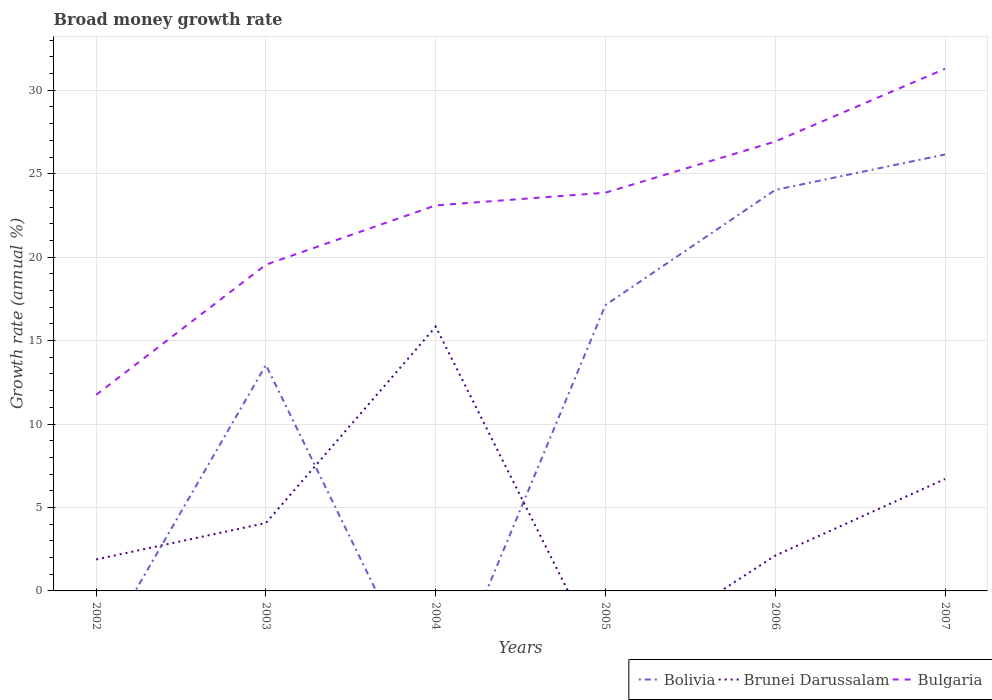How many different coloured lines are there?
Your answer should be compact. 3. Does the line corresponding to Bulgaria intersect with the line corresponding to Bolivia?
Offer a terse response. No. Is the number of lines equal to the number of legend labels?
Offer a terse response. No. Across all years, what is the maximum growth rate in Bulgaria?
Your response must be concise. 11.75. What is the total growth rate in Brunei Darussalam in the graph?
Provide a succinct answer. -4.82. What is the difference between the highest and the second highest growth rate in Bolivia?
Give a very brief answer. 26.15. Is the growth rate in Bulgaria strictly greater than the growth rate in Bolivia over the years?
Make the answer very short. No. How many lines are there?
Ensure brevity in your answer.  3. What is the difference between two consecutive major ticks on the Y-axis?
Provide a short and direct response. 5. Are the values on the major ticks of Y-axis written in scientific E-notation?
Give a very brief answer. No. Does the graph contain any zero values?
Provide a short and direct response. Yes. Does the graph contain grids?
Offer a terse response. Yes. Where does the legend appear in the graph?
Make the answer very short. Bottom right. How many legend labels are there?
Your answer should be compact. 3. What is the title of the graph?
Provide a succinct answer. Broad money growth rate. Does "Congo (Republic)" appear as one of the legend labels in the graph?
Keep it short and to the point. No. What is the label or title of the Y-axis?
Your answer should be compact. Growth rate (annual %). What is the Growth rate (annual %) in Brunei Darussalam in 2002?
Your answer should be compact. 1.89. What is the Growth rate (annual %) of Bulgaria in 2002?
Keep it short and to the point. 11.75. What is the Growth rate (annual %) of Bolivia in 2003?
Your response must be concise. 13.54. What is the Growth rate (annual %) in Brunei Darussalam in 2003?
Your response must be concise. 4.07. What is the Growth rate (annual %) of Bulgaria in 2003?
Offer a very short reply. 19.55. What is the Growth rate (annual %) of Brunei Darussalam in 2004?
Your answer should be very brief. 15.83. What is the Growth rate (annual %) in Bulgaria in 2004?
Your answer should be compact. 23.1. What is the Growth rate (annual %) in Bolivia in 2005?
Your answer should be compact. 17.13. What is the Growth rate (annual %) of Brunei Darussalam in 2005?
Make the answer very short. 0. What is the Growth rate (annual %) in Bulgaria in 2005?
Your answer should be compact. 23.86. What is the Growth rate (annual %) in Bolivia in 2006?
Provide a short and direct response. 24.03. What is the Growth rate (annual %) in Brunei Darussalam in 2006?
Give a very brief answer. 2.12. What is the Growth rate (annual %) of Bulgaria in 2006?
Keep it short and to the point. 26.93. What is the Growth rate (annual %) of Bolivia in 2007?
Ensure brevity in your answer.  26.15. What is the Growth rate (annual %) of Brunei Darussalam in 2007?
Keep it short and to the point. 6.71. What is the Growth rate (annual %) of Bulgaria in 2007?
Your answer should be very brief. 31.29. Across all years, what is the maximum Growth rate (annual %) of Bolivia?
Make the answer very short. 26.15. Across all years, what is the maximum Growth rate (annual %) of Brunei Darussalam?
Offer a very short reply. 15.83. Across all years, what is the maximum Growth rate (annual %) in Bulgaria?
Keep it short and to the point. 31.29. Across all years, what is the minimum Growth rate (annual %) of Bulgaria?
Offer a terse response. 11.75. What is the total Growth rate (annual %) in Bolivia in the graph?
Keep it short and to the point. 80.85. What is the total Growth rate (annual %) of Brunei Darussalam in the graph?
Ensure brevity in your answer.  30.61. What is the total Growth rate (annual %) of Bulgaria in the graph?
Your response must be concise. 136.47. What is the difference between the Growth rate (annual %) in Brunei Darussalam in 2002 and that in 2003?
Offer a terse response. -2.19. What is the difference between the Growth rate (annual %) in Bulgaria in 2002 and that in 2003?
Offer a terse response. -7.8. What is the difference between the Growth rate (annual %) of Brunei Darussalam in 2002 and that in 2004?
Offer a terse response. -13.95. What is the difference between the Growth rate (annual %) in Bulgaria in 2002 and that in 2004?
Give a very brief answer. -11.35. What is the difference between the Growth rate (annual %) in Bulgaria in 2002 and that in 2005?
Provide a succinct answer. -12.11. What is the difference between the Growth rate (annual %) of Brunei Darussalam in 2002 and that in 2006?
Keep it short and to the point. -0.23. What is the difference between the Growth rate (annual %) in Bulgaria in 2002 and that in 2006?
Your answer should be compact. -15.18. What is the difference between the Growth rate (annual %) of Brunei Darussalam in 2002 and that in 2007?
Give a very brief answer. -4.82. What is the difference between the Growth rate (annual %) in Bulgaria in 2002 and that in 2007?
Your response must be concise. -19.54. What is the difference between the Growth rate (annual %) in Brunei Darussalam in 2003 and that in 2004?
Provide a short and direct response. -11.76. What is the difference between the Growth rate (annual %) in Bulgaria in 2003 and that in 2004?
Keep it short and to the point. -3.55. What is the difference between the Growth rate (annual %) in Bolivia in 2003 and that in 2005?
Give a very brief answer. -3.59. What is the difference between the Growth rate (annual %) of Bulgaria in 2003 and that in 2005?
Provide a short and direct response. -4.31. What is the difference between the Growth rate (annual %) of Bolivia in 2003 and that in 2006?
Keep it short and to the point. -10.49. What is the difference between the Growth rate (annual %) of Brunei Darussalam in 2003 and that in 2006?
Ensure brevity in your answer.  1.95. What is the difference between the Growth rate (annual %) of Bulgaria in 2003 and that in 2006?
Your answer should be compact. -7.38. What is the difference between the Growth rate (annual %) of Bolivia in 2003 and that in 2007?
Make the answer very short. -12.61. What is the difference between the Growth rate (annual %) in Brunei Darussalam in 2003 and that in 2007?
Your response must be concise. -2.64. What is the difference between the Growth rate (annual %) of Bulgaria in 2003 and that in 2007?
Make the answer very short. -11.74. What is the difference between the Growth rate (annual %) of Bulgaria in 2004 and that in 2005?
Offer a terse response. -0.76. What is the difference between the Growth rate (annual %) in Brunei Darussalam in 2004 and that in 2006?
Your answer should be very brief. 13.72. What is the difference between the Growth rate (annual %) of Bulgaria in 2004 and that in 2006?
Provide a short and direct response. -3.83. What is the difference between the Growth rate (annual %) in Brunei Darussalam in 2004 and that in 2007?
Keep it short and to the point. 9.13. What is the difference between the Growth rate (annual %) of Bulgaria in 2004 and that in 2007?
Keep it short and to the point. -8.19. What is the difference between the Growth rate (annual %) of Bolivia in 2005 and that in 2006?
Your response must be concise. -6.89. What is the difference between the Growth rate (annual %) in Bulgaria in 2005 and that in 2006?
Provide a succinct answer. -3.07. What is the difference between the Growth rate (annual %) of Bolivia in 2005 and that in 2007?
Offer a terse response. -9.02. What is the difference between the Growth rate (annual %) in Bulgaria in 2005 and that in 2007?
Offer a very short reply. -7.42. What is the difference between the Growth rate (annual %) of Bolivia in 2006 and that in 2007?
Ensure brevity in your answer.  -2.12. What is the difference between the Growth rate (annual %) in Brunei Darussalam in 2006 and that in 2007?
Your answer should be compact. -4.59. What is the difference between the Growth rate (annual %) of Bulgaria in 2006 and that in 2007?
Provide a succinct answer. -4.36. What is the difference between the Growth rate (annual %) of Brunei Darussalam in 2002 and the Growth rate (annual %) of Bulgaria in 2003?
Give a very brief answer. -17.66. What is the difference between the Growth rate (annual %) in Brunei Darussalam in 2002 and the Growth rate (annual %) in Bulgaria in 2004?
Your answer should be very brief. -21.22. What is the difference between the Growth rate (annual %) in Brunei Darussalam in 2002 and the Growth rate (annual %) in Bulgaria in 2005?
Offer a terse response. -21.98. What is the difference between the Growth rate (annual %) of Brunei Darussalam in 2002 and the Growth rate (annual %) of Bulgaria in 2006?
Your response must be concise. -25.04. What is the difference between the Growth rate (annual %) of Brunei Darussalam in 2002 and the Growth rate (annual %) of Bulgaria in 2007?
Offer a very short reply. -29.4. What is the difference between the Growth rate (annual %) of Bolivia in 2003 and the Growth rate (annual %) of Brunei Darussalam in 2004?
Give a very brief answer. -2.29. What is the difference between the Growth rate (annual %) in Bolivia in 2003 and the Growth rate (annual %) in Bulgaria in 2004?
Your response must be concise. -9.56. What is the difference between the Growth rate (annual %) in Brunei Darussalam in 2003 and the Growth rate (annual %) in Bulgaria in 2004?
Ensure brevity in your answer.  -19.03. What is the difference between the Growth rate (annual %) of Bolivia in 2003 and the Growth rate (annual %) of Bulgaria in 2005?
Your response must be concise. -10.32. What is the difference between the Growth rate (annual %) in Brunei Darussalam in 2003 and the Growth rate (annual %) in Bulgaria in 2005?
Give a very brief answer. -19.79. What is the difference between the Growth rate (annual %) of Bolivia in 2003 and the Growth rate (annual %) of Brunei Darussalam in 2006?
Your response must be concise. 11.42. What is the difference between the Growth rate (annual %) in Bolivia in 2003 and the Growth rate (annual %) in Bulgaria in 2006?
Keep it short and to the point. -13.39. What is the difference between the Growth rate (annual %) of Brunei Darussalam in 2003 and the Growth rate (annual %) of Bulgaria in 2006?
Your answer should be compact. -22.86. What is the difference between the Growth rate (annual %) in Bolivia in 2003 and the Growth rate (annual %) in Brunei Darussalam in 2007?
Your answer should be very brief. 6.83. What is the difference between the Growth rate (annual %) in Bolivia in 2003 and the Growth rate (annual %) in Bulgaria in 2007?
Offer a terse response. -17.75. What is the difference between the Growth rate (annual %) of Brunei Darussalam in 2003 and the Growth rate (annual %) of Bulgaria in 2007?
Offer a very short reply. -27.21. What is the difference between the Growth rate (annual %) of Brunei Darussalam in 2004 and the Growth rate (annual %) of Bulgaria in 2005?
Ensure brevity in your answer.  -8.03. What is the difference between the Growth rate (annual %) of Brunei Darussalam in 2004 and the Growth rate (annual %) of Bulgaria in 2006?
Make the answer very short. -11.09. What is the difference between the Growth rate (annual %) in Brunei Darussalam in 2004 and the Growth rate (annual %) in Bulgaria in 2007?
Offer a terse response. -15.45. What is the difference between the Growth rate (annual %) in Bolivia in 2005 and the Growth rate (annual %) in Brunei Darussalam in 2006?
Provide a succinct answer. 15.02. What is the difference between the Growth rate (annual %) in Bolivia in 2005 and the Growth rate (annual %) in Bulgaria in 2006?
Your response must be concise. -9.79. What is the difference between the Growth rate (annual %) of Bolivia in 2005 and the Growth rate (annual %) of Brunei Darussalam in 2007?
Make the answer very short. 10.43. What is the difference between the Growth rate (annual %) in Bolivia in 2005 and the Growth rate (annual %) in Bulgaria in 2007?
Ensure brevity in your answer.  -14.15. What is the difference between the Growth rate (annual %) in Bolivia in 2006 and the Growth rate (annual %) in Brunei Darussalam in 2007?
Give a very brief answer. 17.32. What is the difference between the Growth rate (annual %) in Bolivia in 2006 and the Growth rate (annual %) in Bulgaria in 2007?
Keep it short and to the point. -7.26. What is the difference between the Growth rate (annual %) of Brunei Darussalam in 2006 and the Growth rate (annual %) of Bulgaria in 2007?
Provide a short and direct response. -29.17. What is the average Growth rate (annual %) of Bolivia per year?
Ensure brevity in your answer.  13.48. What is the average Growth rate (annual %) of Brunei Darussalam per year?
Ensure brevity in your answer.  5.1. What is the average Growth rate (annual %) in Bulgaria per year?
Your response must be concise. 22.75. In the year 2002, what is the difference between the Growth rate (annual %) in Brunei Darussalam and Growth rate (annual %) in Bulgaria?
Ensure brevity in your answer.  -9.86. In the year 2003, what is the difference between the Growth rate (annual %) of Bolivia and Growth rate (annual %) of Brunei Darussalam?
Offer a very short reply. 9.47. In the year 2003, what is the difference between the Growth rate (annual %) in Bolivia and Growth rate (annual %) in Bulgaria?
Ensure brevity in your answer.  -6.01. In the year 2003, what is the difference between the Growth rate (annual %) of Brunei Darussalam and Growth rate (annual %) of Bulgaria?
Provide a short and direct response. -15.48. In the year 2004, what is the difference between the Growth rate (annual %) in Brunei Darussalam and Growth rate (annual %) in Bulgaria?
Ensure brevity in your answer.  -7.27. In the year 2005, what is the difference between the Growth rate (annual %) of Bolivia and Growth rate (annual %) of Bulgaria?
Ensure brevity in your answer.  -6.73. In the year 2006, what is the difference between the Growth rate (annual %) of Bolivia and Growth rate (annual %) of Brunei Darussalam?
Give a very brief answer. 21.91. In the year 2006, what is the difference between the Growth rate (annual %) of Bolivia and Growth rate (annual %) of Bulgaria?
Your answer should be very brief. -2.9. In the year 2006, what is the difference between the Growth rate (annual %) in Brunei Darussalam and Growth rate (annual %) in Bulgaria?
Offer a very short reply. -24.81. In the year 2007, what is the difference between the Growth rate (annual %) of Bolivia and Growth rate (annual %) of Brunei Darussalam?
Keep it short and to the point. 19.44. In the year 2007, what is the difference between the Growth rate (annual %) of Bolivia and Growth rate (annual %) of Bulgaria?
Your answer should be compact. -5.14. In the year 2007, what is the difference between the Growth rate (annual %) of Brunei Darussalam and Growth rate (annual %) of Bulgaria?
Offer a very short reply. -24.58. What is the ratio of the Growth rate (annual %) in Brunei Darussalam in 2002 to that in 2003?
Keep it short and to the point. 0.46. What is the ratio of the Growth rate (annual %) in Bulgaria in 2002 to that in 2003?
Provide a succinct answer. 0.6. What is the ratio of the Growth rate (annual %) in Brunei Darussalam in 2002 to that in 2004?
Give a very brief answer. 0.12. What is the ratio of the Growth rate (annual %) in Bulgaria in 2002 to that in 2004?
Ensure brevity in your answer.  0.51. What is the ratio of the Growth rate (annual %) in Bulgaria in 2002 to that in 2005?
Your answer should be very brief. 0.49. What is the ratio of the Growth rate (annual %) of Brunei Darussalam in 2002 to that in 2006?
Provide a succinct answer. 0.89. What is the ratio of the Growth rate (annual %) of Bulgaria in 2002 to that in 2006?
Offer a very short reply. 0.44. What is the ratio of the Growth rate (annual %) in Brunei Darussalam in 2002 to that in 2007?
Offer a very short reply. 0.28. What is the ratio of the Growth rate (annual %) in Bulgaria in 2002 to that in 2007?
Your answer should be compact. 0.38. What is the ratio of the Growth rate (annual %) in Brunei Darussalam in 2003 to that in 2004?
Your answer should be very brief. 0.26. What is the ratio of the Growth rate (annual %) of Bulgaria in 2003 to that in 2004?
Your answer should be compact. 0.85. What is the ratio of the Growth rate (annual %) of Bolivia in 2003 to that in 2005?
Make the answer very short. 0.79. What is the ratio of the Growth rate (annual %) of Bulgaria in 2003 to that in 2005?
Give a very brief answer. 0.82. What is the ratio of the Growth rate (annual %) in Bolivia in 2003 to that in 2006?
Offer a terse response. 0.56. What is the ratio of the Growth rate (annual %) of Brunei Darussalam in 2003 to that in 2006?
Provide a succinct answer. 1.92. What is the ratio of the Growth rate (annual %) of Bulgaria in 2003 to that in 2006?
Ensure brevity in your answer.  0.73. What is the ratio of the Growth rate (annual %) of Bolivia in 2003 to that in 2007?
Provide a short and direct response. 0.52. What is the ratio of the Growth rate (annual %) of Brunei Darussalam in 2003 to that in 2007?
Your answer should be compact. 0.61. What is the ratio of the Growth rate (annual %) of Bulgaria in 2003 to that in 2007?
Offer a very short reply. 0.62. What is the ratio of the Growth rate (annual %) of Bulgaria in 2004 to that in 2005?
Ensure brevity in your answer.  0.97. What is the ratio of the Growth rate (annual %) in Brunei Darussalam in 2004 to that in 2006?
Offer a terse response. 7.48. What is the ratio of the Growth rate (annual %) of Bulgaria in 2004 to that in 2006?
Make the answer very short. 0.86. What is the ratio of the Growth rate (annual %) in Brunei Darussalam in 2004 to that in 2007?
Your answer should be very brief. 2.36. What is the ratio of the Growth rate (annual %) in Bulgaria in 2004 to that in 2007?
Offer a terse response. 0.74. What is the ratio of the Growth rate (annual %) in Bolivia in 2005 to that in 2006?
Offer a terse response. 0.71. What is the ratio of the Growth rate (annual %) in Bulgaria in 2005 to that in 2006?
Your response must be concise. 0.89. What is the ratio of the Growth rate (annual %) in Bolivia in 2005 to that in 2007?
Ensure brevity in your answer.  0.66. What is the ratio of the Growth rate (annual %) in Bulgaria in 2005 to that in 2007?
Your response must be concise. 0.76. What is the ratio of the Growth rate (annual %) in Bolivia in 2006 to that in 2007?
Your answer should be very brief. 0.92. What is the ratio of the Growth rate (annual %) of Brunei Darussalam in 2006 to that in 2007?
Keep it short and to the point. 0.32. What is the ratio of the Growth rate (annual %) in Bulgaria in 2006 to that in 2007?
Your response must be concise. 0.86. What is the difference between the highest and the second highest Growth rate (annual %) of Bolivia?
Give a very brief answer. 2.12. What is the difference between the highest and the second highest Growth rate (annual %) of Brunei Darussalam?
Keep it short and to the point. 9.13. What is the difference between the highest and the second highest Growth rate (annual %) in Bulgaria?
Your response must be concise. 4.36. What is the difference between the highest and the lowest Growth rate (annual %) of Bolivia?
Make the answer very short. 26.15. What is the difference between the highest and the lowest Growth rate (annual %) in Brunei Darussalam?
Ensure brevity in your answer.  15.83. What is the difference between the highest and the lowest Growth rate (annual %) in Bulgaria?
Offer a very short reply. 19.54. 